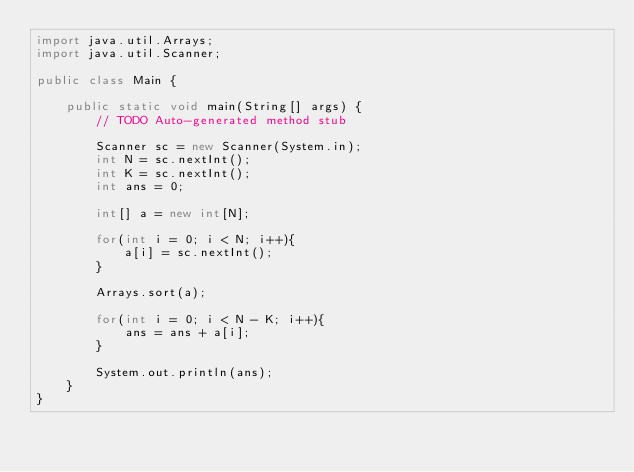<code> <loc_0><loc_0><loc_500><loc_500><_Java_>import java.util.Arrays;
import java.util.Scanner;

public class Main {

	public static void main(String[] args) {
		// TODO Auto-generated method stub

		Scanner sc = new Scanner(System.in);
		int N = sc.nextInt();
		int K = sc.nextInt();
		int ans = 0;
		
		int[] a = new int[N];
		
		for(int i = 0; i < N; i++){
			a[i] = sc.nextInt();
		}
		
		Arrays.sort(a);
		
		for(int i = 0; i < N - K; i++){
			ans = ans + a[i];
		}
		
		System.out.println(ans);
	}
}
</code> 